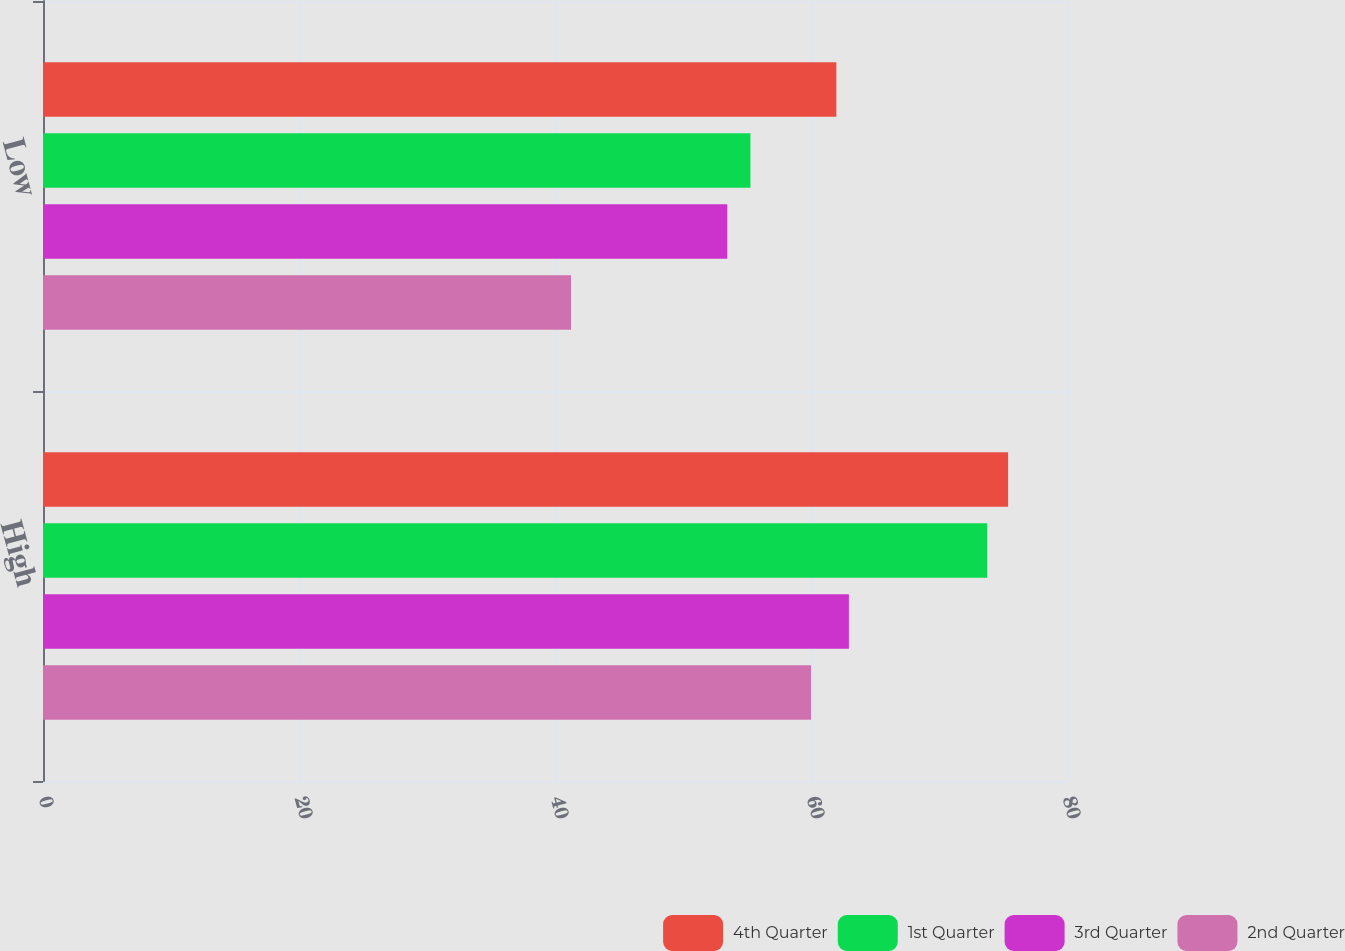Convert chart. <chart><loc_0><loc_0><loc_500><loc_500><stacked_bar_chart><ecel><fcel>High<fcel>Low<nl><fcel>4th Quarter<fcel>75.4<fcel>61.98<nl><fcel>1st Quarter<fcel>73.76<fcel>55.27<nl><fcel>3rd Quarter<fcel>62.96<fcel>53.46<nl><fcel>2nd Quarter<fcel>60<fcel>41.25<nl></chart> 